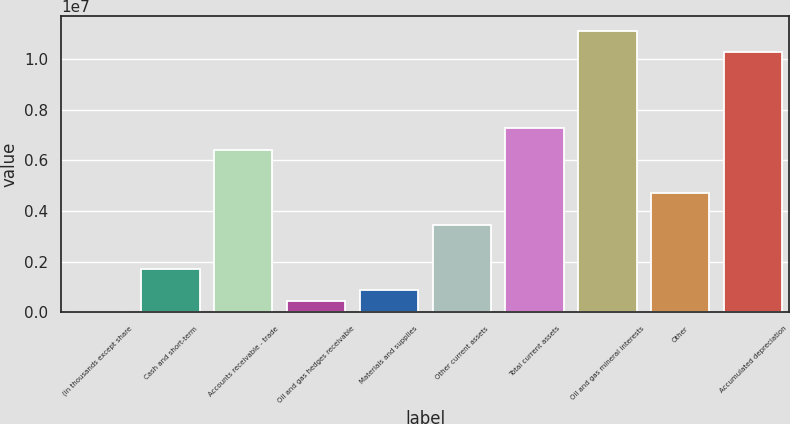<chart> <loc_0><loc_0><loc_500><loc_500><bar_chart><fcel>(in thousands except share<fcel>Cash and short-term<fcel>Accounts receivable - trade<fcel>Oil and gas hedges receivable<fcel>Materials and supplies<fcel>Other current assets<fcel>Total current assets<fcel>Oil and gas mineral interests<fcel>Other<fcel>Accumulated depreciation<nl><fcel>2002<fcel>1.7154e+06<fcel>6.42726e+06<fcel>430353<fcel>858703<fcel>3.42881e+06<fcel>7.28396e+06<fcel>1.11391e+07<fcel>4.71386e+06<fcel>1.02824e+07<nl></chart> 